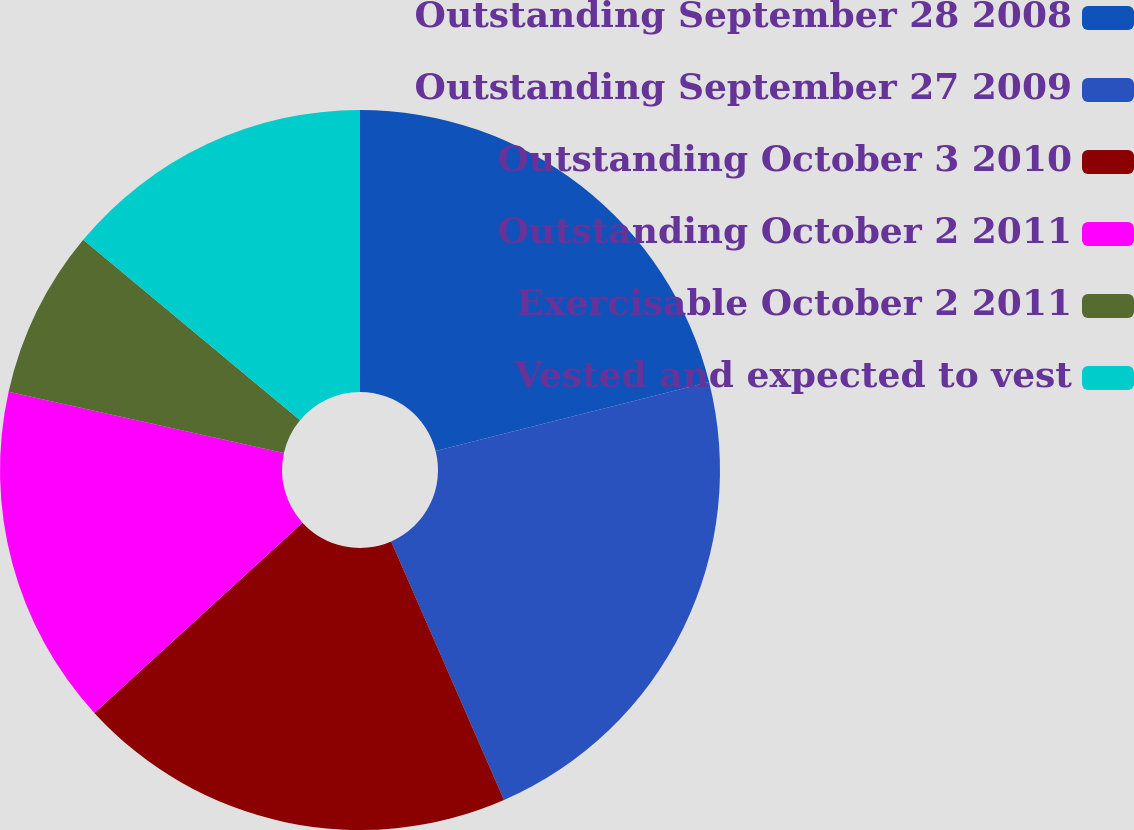Convert chart. <chart><loc_0><loc_0><loc_500><loc_500><pie_chart><fcel>Outstanding September 28 2008<fcel>Outstanding September 27 2009<fcel>Outstanding October 3 2010<fcel>Outstanding October 2 2011<fcel>Exercisable October 2 2011<fcel>Vested and expected to vest<nl><fcel>21.07%<fcel>22.38%<fcel>19.76%<fcel>15.28%<fcel>7.55%<fcel>13.96%<nl></chart> 